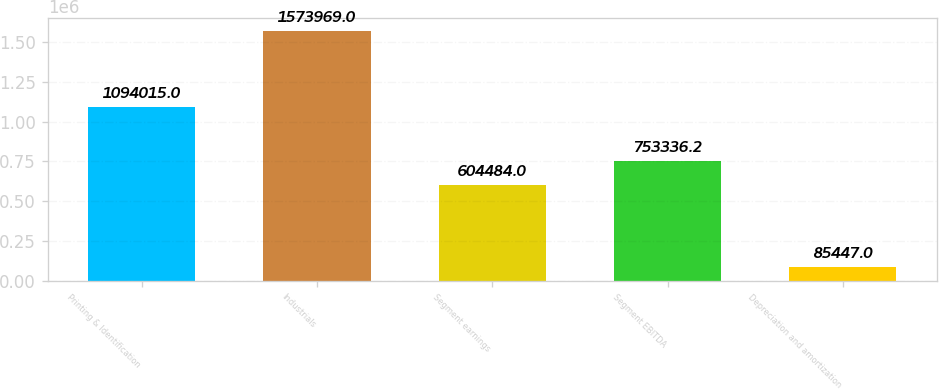Convert chart to OTSL. <chart><loc_0><loc_0><loc_500><loc_500><bar_chart><fcel>Printing & Identification<fcel>Industrials<fcel>Segment earnings<fcel>Segment EBITDA<fcel>Depreciation and amortization<nl><fcel>1.09402e+06<fcel>1.57397e+06<fcel>604484<fcel>753336<fcel>85447<nl></chart> 